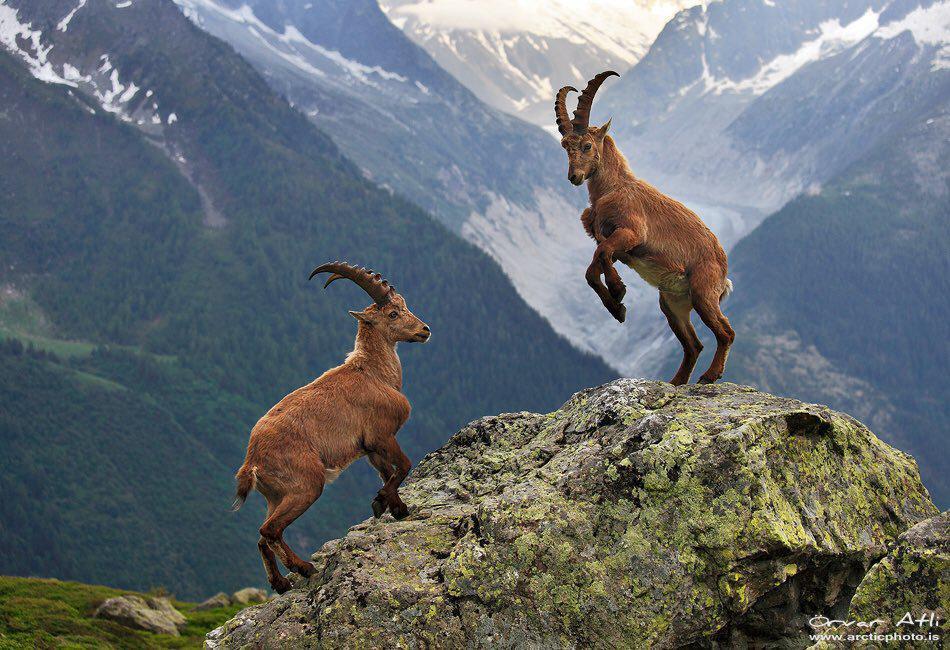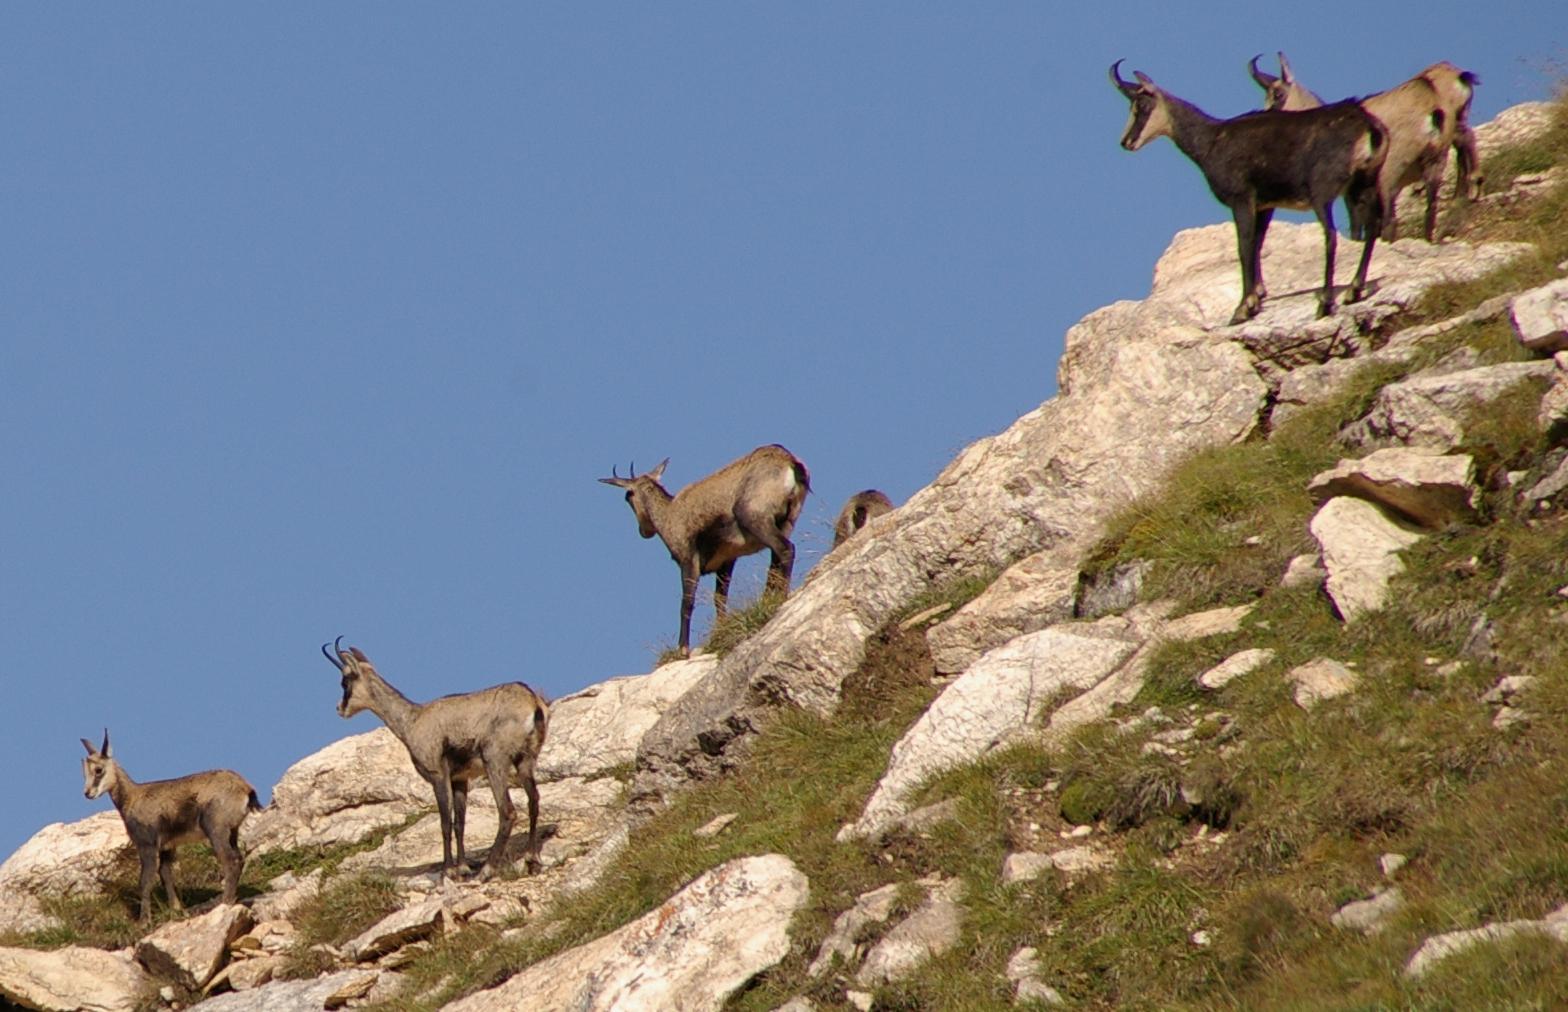The first image is the image on the left, the second image is the image on the right. Assess this claim about the two images: "In at least one image there is a lone Ibex on rocky ground". Correct or not? Answer yes or no. No. The first image is the image on the left, the second image is the image on the right. Analyze the images presented: Is the assertion "Two rams are facing each other on top of a boulder in the mountains in one image." valid? Answer yes or no. Yes. 